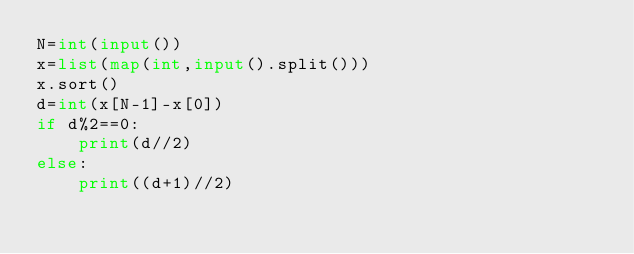Convert code to text. <code><loc_0><loc_0><loc_500><loc_500><_Python_>N=int(input())
x=list(map(int,input().split()))
x.sort()
d=int(x[N-1]-x[0])
if d%2==0:
    print(d//2)
else:
    print((d+1)//2)
</code> 